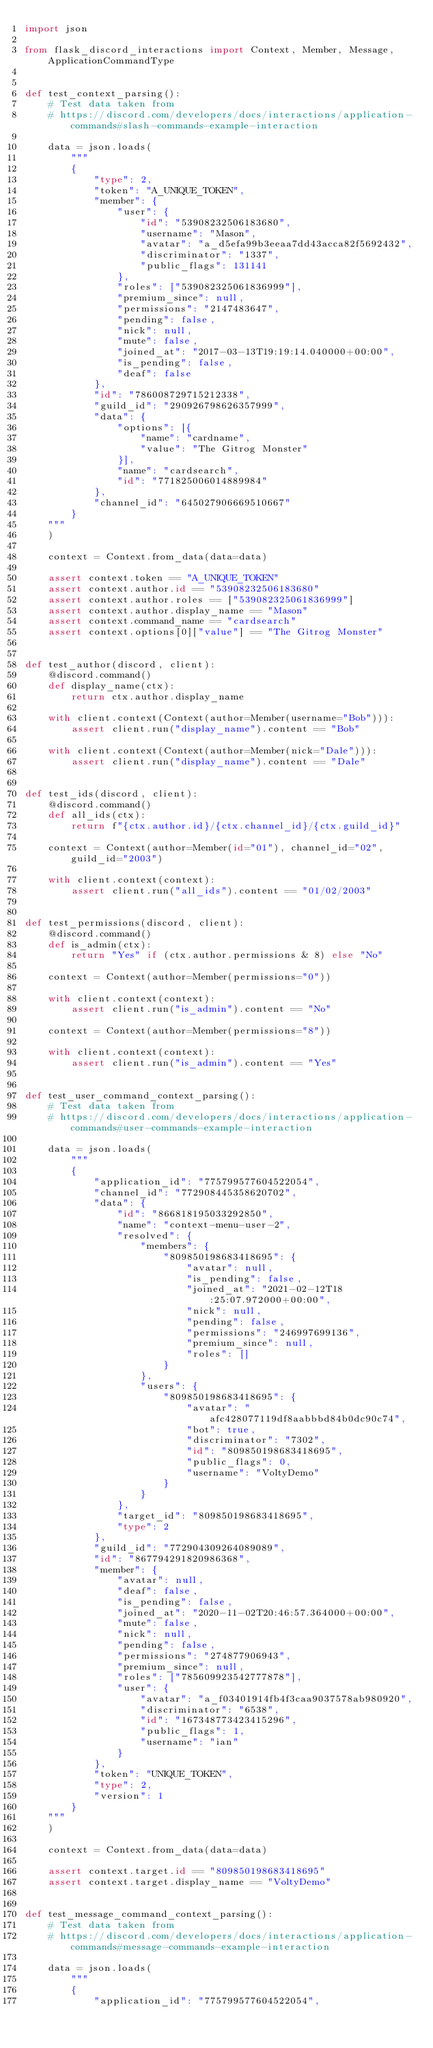<code> <loc_0><loc_0><loc_500><loc_500><_Python_>import json

from flask_discord_interactions import Context, Member, Message, ApplicationCommandType


def test_context_parsing():
    # Test data taken from
    # https://discord.com/developers/docs/interactions/application-commands#slash-commands-example-interaction

    data = json.loads(
        """
        {
            "type": 2,
            "token": "A_UNIQUE_TOKEN",
            "member": {
                "user": {
                    "id": "53908232506183680",
                    "username": "Mason",
                    "avatar": "a_d5efa99b3eeaa7dd43acca82f5692432",
                    "discriminator": "1337",
                    "public_flags": 131141
                },
                "roles": ["539082325061836999"],
                "premium_since": null,
                "permissions": "2147483647",
                "pending": false,
                "nick": null,
                "mute": false,
                "joined_at": "2017-03-13T19:19:14.040000+00:00",
                "is_pending": false,
                "deaf": false
            },
            "id": "786008729715212338",
            "guild_id": "290926798626357999",
            "data": {
                "options": [{
                    "name": "cardname",
                    "value": "The Gitrog Monster"
                }],
                "name": "cardsearch",
                "id": "771825006014889984"
            },
            "channel_id": "645027906669510667"
        }
    """
    )

    context = Context.from_data(data=data)

    assert context.token == "A_UNIQUE_TOKEN"
    assert context.author.id == "53908232506183680"
    assert context.author.roles == ["539082325061836999"]
    assert context.author.display_name == "Mason"
    assert context.command_name == "cardsearch"
    assert context.options[0]["value"] == "The Gitrog Monster"


def test_author(discord, client):
    @discord.command()
    def display_name(ctx):
        return ctx.author.display_name

    with client.context(Context(author=Member(username="Bob"))):
        assert client.run("display_name").content == "Bob"

    with client.context(Context(author=Member(nick="Dale"))):
        assert client.run("display_name").content == "Dale"


def test_ids(discord, client):
    @discord.command()
    def all_ids(ctx):
        return f"{ctx.author.id}/{ctx.channel_id}/{ctx.guild_id}"

    context = Context(author=Member(id="01"), channel_id="02", guild_id="2003")

    with client.context(context):
        assert client.run("all_ids").content == "01/02/2003"


def test_permissions(discord, client):
    @discord.command()
    def is_admin(ctx):
        return "Yes" if (ctx.author.permissions & 8) else "No"

    context = Context(author=Member(permissions="0"))

    with client.context(context):
        assert client.run("is_admin").content == "No"

    context = Context(author=Member(permissions="8"))

    with client.context(context):
        assert client.run("is_admin").content == "Yes"


def test_user_command_context_parsing():
    # Test data taken from
    # https://discord.com/developers/docs/interactions/application-commands#user-commands-example-interaction

    data = json.loads(
        """
        {
            "application_id": "775799577604522054",
            "channel_id": "772908445358620702",
            "data": {
                "id": "866818195033292850",
                "name": "context-menu-user-2",
                "resolved": {
                    "members": {
                        "809850198683418695": {
                            "avatar": null,
                            "is_pending": false,
                            "joined_at": "2021-02-12T18:25:07.972000+00:00",
                            "nick": null,
                            "pending": false,
                            "permissions": "246997699136",
                            "premium_since": null,
                            "roles": []
                        }
                    },
                    "users": {
                        "809850198683418695": {
                            "avatar": "afc428077119df8aabbbd84b0dc90c74",
                            "bot": true,
                            "discriminator": "7302",
                            "id": "809850198683418695",
                            "public_flags": 0,
                            "username": "VoltyDemo"
                        }
                    }
                },
                "target_id": "809850198683418695",
                "type": 2
            },
            "guild_id": "772904309264089089",
            "id": "867794291820986368",
            "member": {
                "avatar": null,
                "deaf": false,
                "is_pending": false,
                "joined_at": "2020-11-02T20:46:57.364000+00:00",
                "mute": false,
                "nick": null,
                "pending": false,
                "permissions": "274877906943",
                "premium_since": null,
                "roles": ["785609923542777878"],
                "user": {
                    "avatar": "a_f03401914fb4f3caa9037578ab980920",
                    "discriminator": "6538",
                    "id": "167348773423415296",
                    "public_flags": 1,
                    "username": "ian"
                }
            },
            "token": "UNIQUE_TOKEN",
            "type": 2,
            "version": 1
        }
    """
    )

    context = Context.from_data(data=data)

    assert context.target.id == "809850198683418695"
    assert context.target.display_name == "VoltyDemo"


def test_message_command_context_parsing():
    # Test data taken from
    # https://discord.com/developers/docs/interactions/application-commands#message-commands-example-interaction

    data = json.loads(
        """
        {
            "application_id": "775799577604522054",</code> 